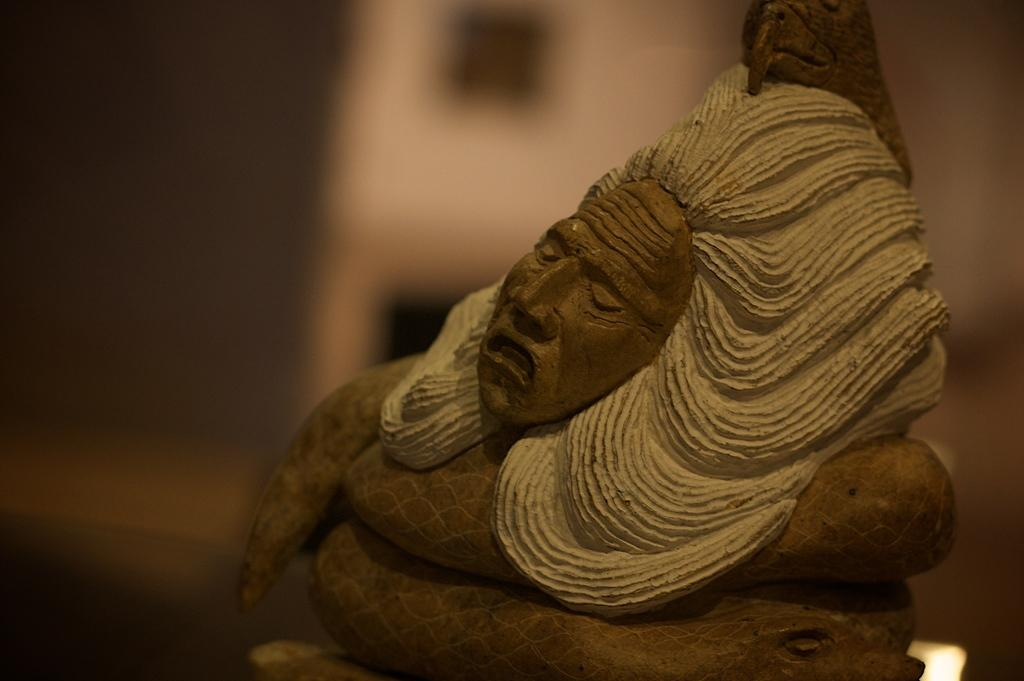What is the main subject of the image? There is a statue in the image. Can you describe the background of the statue? The background of the statue is blurred. What type of mask is the statue wearing in the image? There is no mask present on the statue in the image. Where is the office located in the image? There is no office present in the image; it features a statue with a blurred background. 